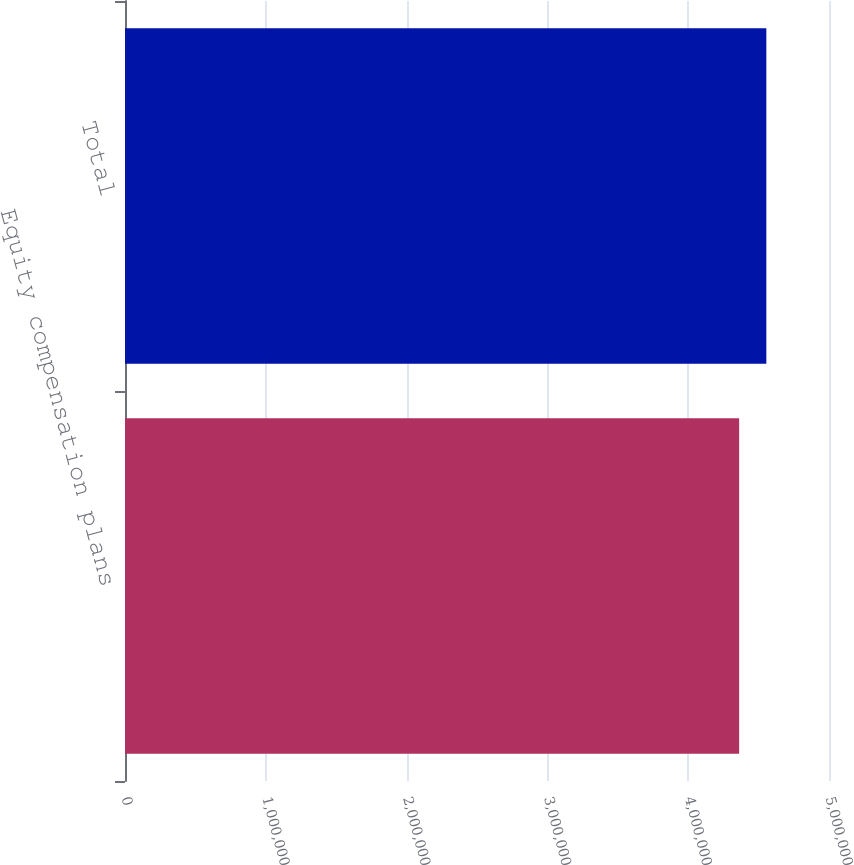<chart> <loc_0><loc_0><loc_500><loc_500><bar_chart><fcel>Equity compensation plans<fcel>Total<nl><fcel>4.36184e+06<fcel>4.55498e+06<nl></chart> 